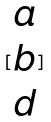Convert formula to latex. <formula><loc_0><loc_0><loc_500><loc_500>[ \begin{matrix} a \\ b \\ d \end{matrix} ]</formula> 